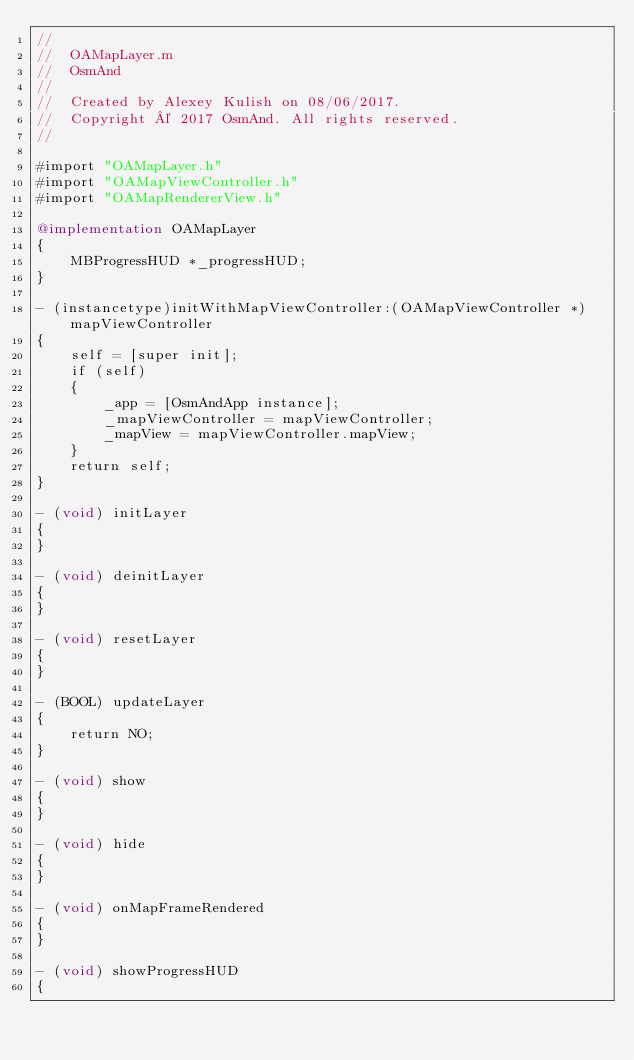Convert code to text. <code><loc_0><loc_0><loc_500><loc_500><_ObjectiveC_>//
//  OAMapLayer.m
//  OsmAnd
//
//  Created by Alexey Kulish on 08/06/2017.
//  Copyright © 2017 OsmAnd. All rights reserved.
//

#import "OAMapLayer.h"
#import "OAMapViewController.h"
#import "OAMapRendererView.h"

@implementation OAMapLayer
{
    MBProgressHUD *_progressHUD;
}

- (instancetype)initWithMapViewController:(OAMapViewController *)mapViewController
{
    self = [super init];
    if (self)
    {
        _app = [OsmAndApp instance];
        _mapViewController = mapViewController;
        _mapView = mapViewController.mapView;
    }
    return self;
}

- (void) initLayer
{
}

- (void) deinitLayer
{
}

- (void) resetLayer
{
}

- (BOOL) updateLayer
{
    return NO;
}

- (void) show
{
}

- (void) hide
{
}

- (void) onMapFrameRendered
{
}

- (void) showProgressHUD
{</code> 